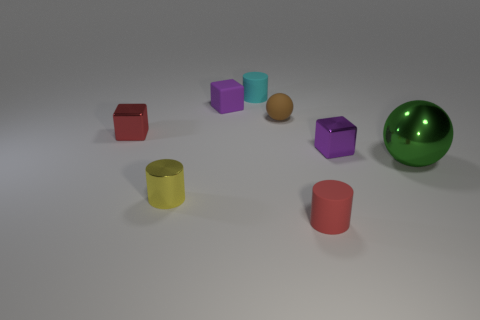Subtract all tiny cyan cylinders. How many cylinders are left? 2 Add 1 brown matte things. How many objects exist? 9 Subtract all red cubes. How many cubes are left? 2 Subtract 3 cylinders. How many cylinders are left? 0 Subtract all cubes. How many objects are left? 5 Add 4 purple metallic things. How many purple metallic things are left? 5 Add 2 small purple objects. How many small purple objects exist? 4 Subtract 0 green cylinders. How many objects are left? 8 Subtract all blue balls. Subtract all cyan cylinders. How many balls are left? 2 Subtract all cyan cylinders. How many blue blocks are left? 0 